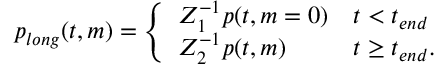<formula> <loc_0><loc_0><loc_500><loc_500>\begin{array} { r } { p _ { l o n g } ( t , m ) = \left \{ \begin{array} { l l } { Z _ { 1 } ^ { - 1 } p ( t , m = 0 ) } & { t < t _ { e n d } } \\ { Z _ { 2 } ^ { - 1 } p ( t , m ) } & { t \geq t _ { e n d } . } \end{array} } \end{array}</formula> 